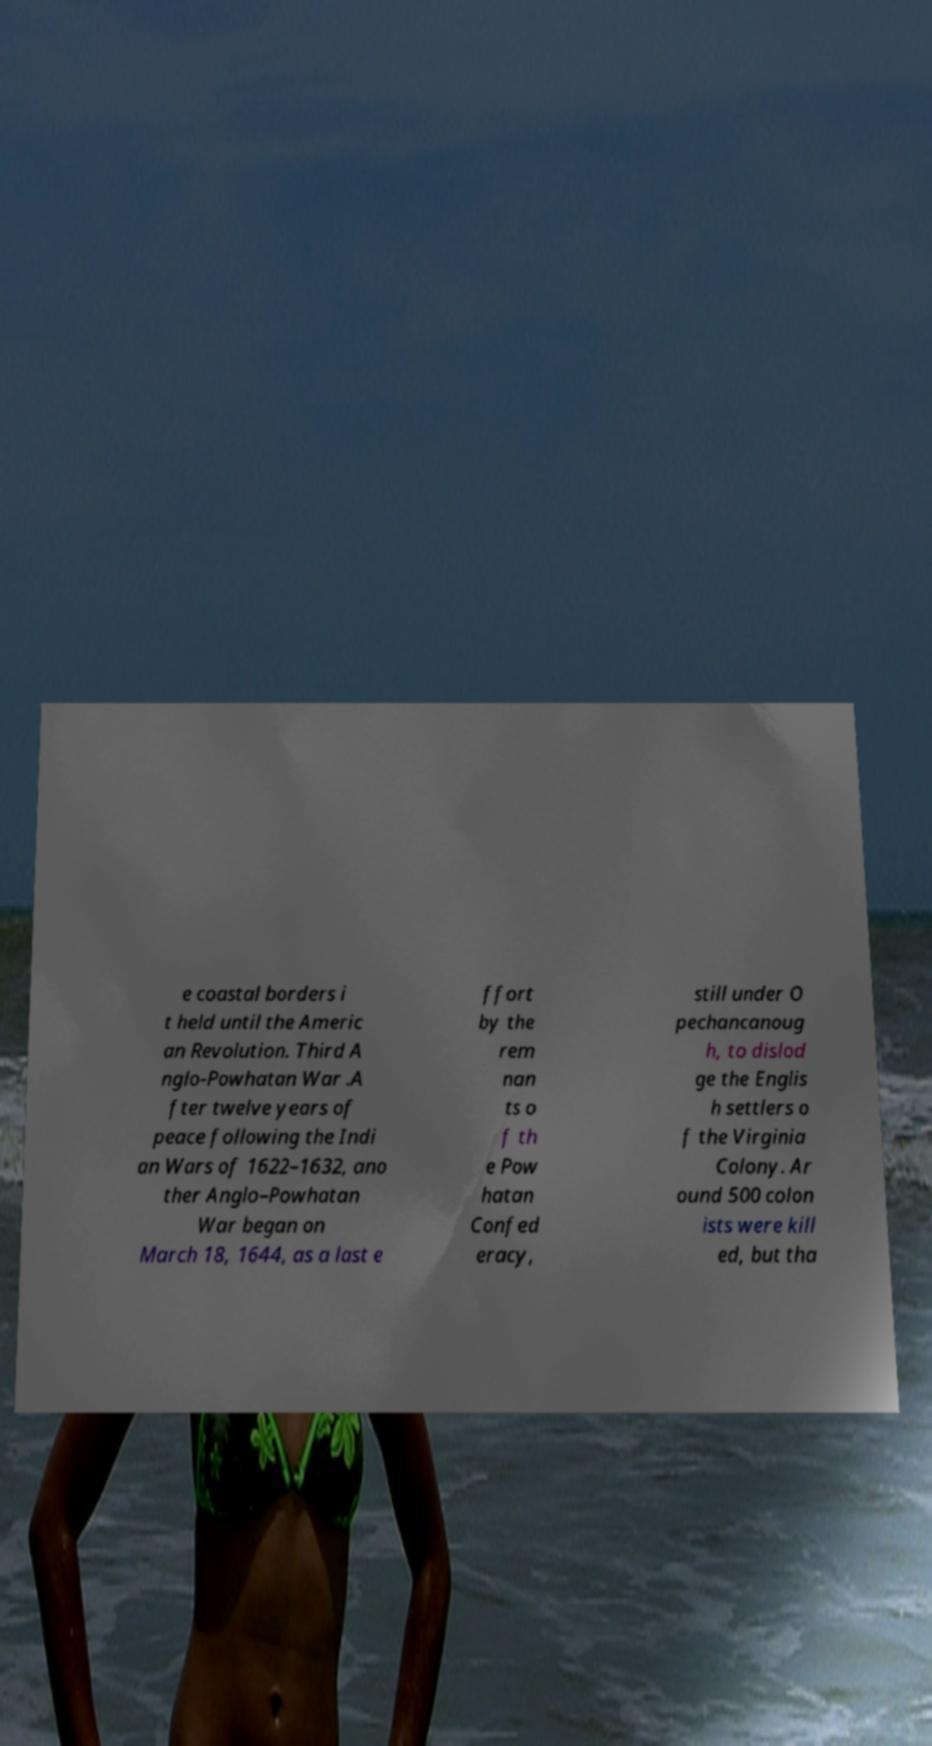Could you assist in decoding the text presented in this image and type it out clearly? e coastal borders i t held until the Americ an Revolution. Third A nglo-Powhatan War .A fter twelve years of peace following the Indi an Wars of 1622–1632, ano ther Anglo–Powhatan War began on March 18, 1644, as a last e ffort by the rem nan ts o f th e Pow hatan Confed eracy, still under O pechancanoug h, to dislod ge the Englis h settlers o f the Virginia Colony. Ar ound 500 colon ists were kill ed, but tha 